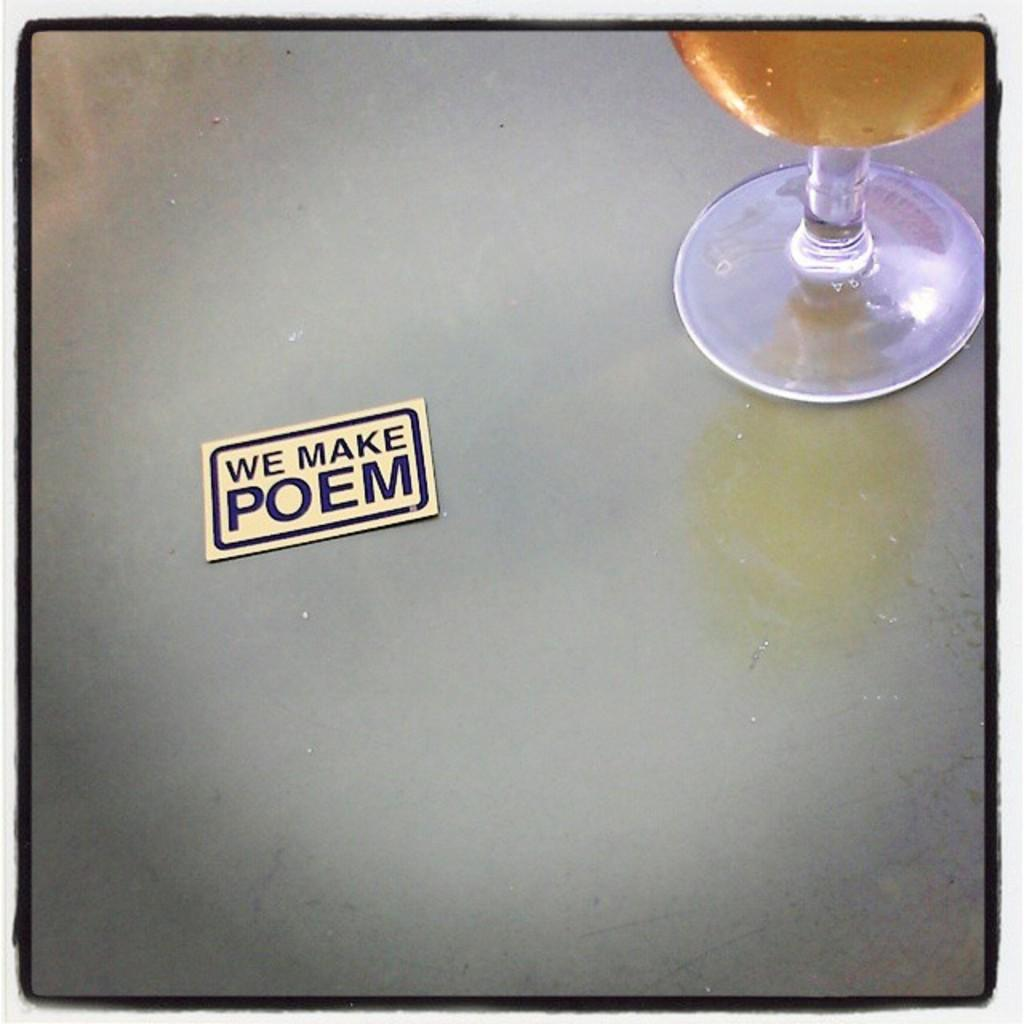<image>
Create a compact narrative representing the image presented. A small card has the phrase we make poem written on it. 